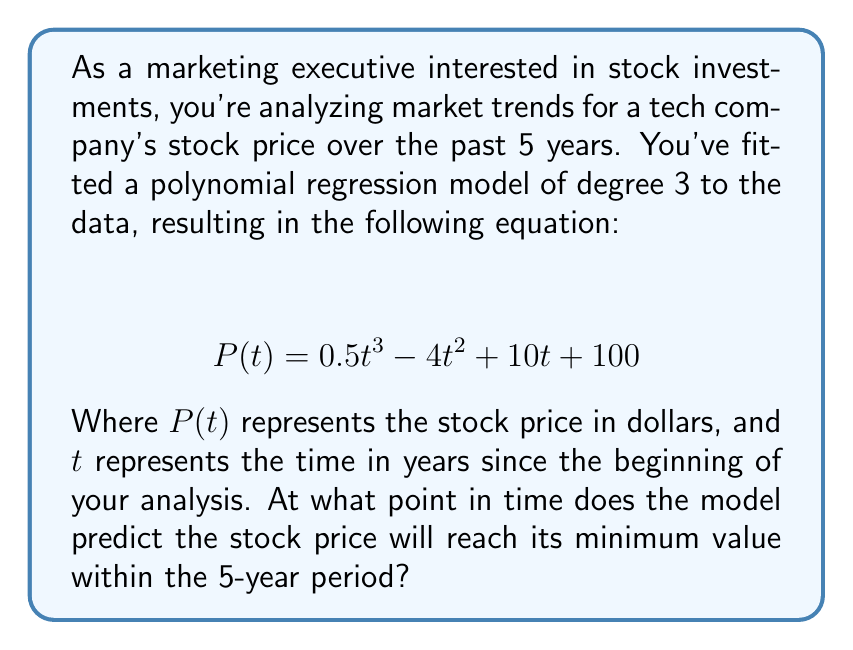Can you solve this math problem? To find the minimum value of the stock price within the 5-year period, we need to follow these steps:

1) First, we need to find the derivative of the polynomial function $P(t)$:

   $$ P'(t) = 1.5t^2 - 8t + 10 $$

2) The minimum (or maximum) points occur where the derivative equals zero. So, we set $P'(t) = 0$:

   $$ 1.5t^2 - 8t + 10 = 0 $$

3) This is a quadratic equation. We can solve it using the quadratic formula:

   $$ t = \frac{-b \pm \sqrt{b^2 - 4ac}}{2a} $$

   Where $a = 1.5$, $b = -8$, and $c = 10$

4) Plugging in these values:

   $$ t = \frac{8 \pm \sqrt{64 - 60}}{3} = \frac{8 \pm 2}{3} $$

5) This gives us two solutions:

   $$ t_1 = \frac{8 + 2}{3} = \frac{10}{3} \approx 3.33 $$
   $$ t_2 = \frac{8 - 2}{3} = 2 $$

6) To determine which of these is the minimum (rather than maximum), we can check the second derivative:

   $$ P''(t) = 3t - 8 $$

7) Plugging in $t = 2$:

   $$ P''(2) = 3(2) - 8 = -2 < 0 $$

   Since the second derivative is negative at $t = 2$, this confirms that this point is a local maximum.

8) Therefore, the minimum occurs at $t = \frac{10}{3} \approx 3.33$ years.

9) We need to check if this point falls within our 5-year period, which it does.

Thus, the model predicts the stock price will reach its minimum value approximately 3.33 years into the 5-year period.
Answer: 3.33 years 